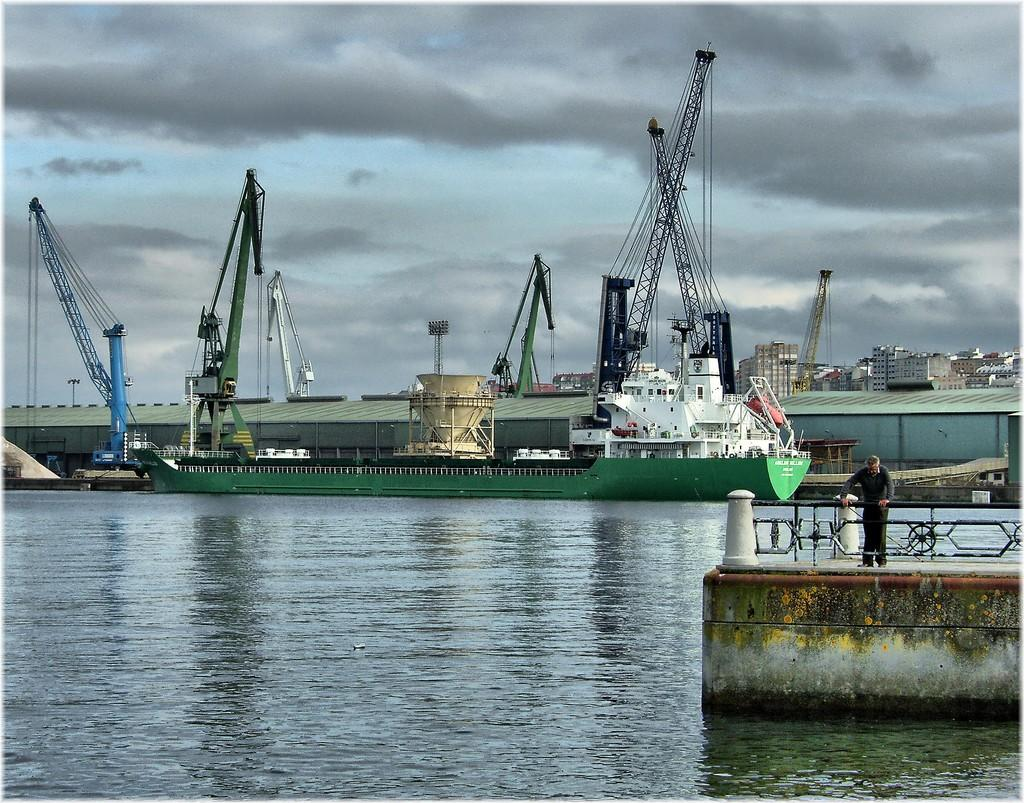What is the main subject in the image? There is a person standing in the image. What can be seen in the water in the image? There is a ship on the water in the image. What is visible in the background of the image? There are buildings and cranes in the background of the image. What part of the natural environment is visible in the image? The sky is visible in the background of the image. What type of wool is being used to create the feeling of peace in the image? There is no wool or reference to peace in the image; it features a person standing near a ship with buildings and cranes in the background. 